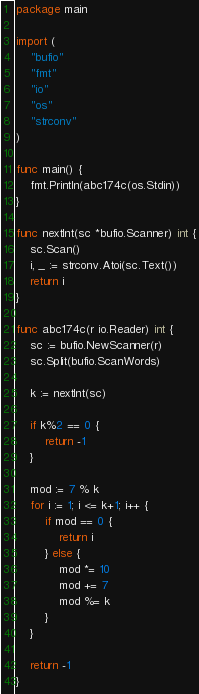Convert code to text. <code><loc_0><loc_0><loc_500><loc_500><_Go_>package main

import (
	"bufio"
	"fmt"
	"io"
	"os"
	"strconv"
)

func main() {
	fmt.Println(abc174c(os.Stdin))
}

func nextInt(sc *bufio.Scanner) int {
	sc.Scan()
	i, _ := strconv.Atoi(sc.Text())
	return i
}

func abc174c(r io.Reader) int {
	sc := bufio.NewScanner(r)
	sc.Split(bufio.ScanWords)

	k := nextInt(sc)

	if k%2 == 0 {
		return -1
	}

	mod := 7 % k
	for i := 1; i <= k+1; i++ {
		if mod == 0 {
			return i
		} else {
			mod *= 10
			mod += 7
			mod %= k
		}
	}

	return -1
}
</code> 